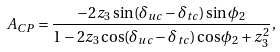<formula> <loc_0><loc_0><loc_500><loc_500>A _ { C P } = \frac { - 2 z _ { 3 } \sin ( \delta _ { u c } - \delta _ { t c } ) \sin \phi _ { 2 } } { 1 - 2 z _ { 3 } \cos ( \delta _ { u c } - \delta _ { t c } ) \cos \phi _ { 2 } + z _ { 3 } ^ { 2 } } ,</formula> 